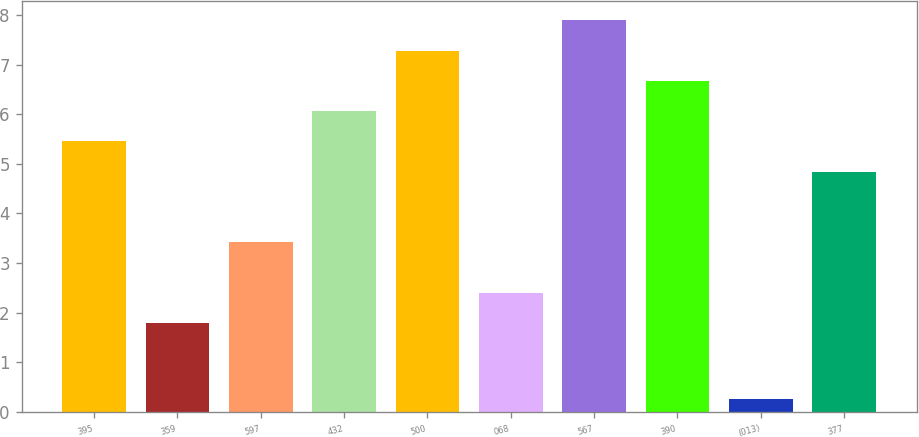<chart> <loc_0><loc_0><loc_500><loc_500><bar_chart><fcel>395<fcel>359<fcel>597<fcel>432<fcel>500<fcel>068<fcel>567<fcel>390<fcel>(013)<fcel>377<nl><fcel>5.45<fcel>1.79<fcel>3.43<fcel>6.06<fcel>7.28<fcel>2.4<fcel>7.89<fcel>6.67<fcel>0.26<fcel>4.84<nl></chart> 